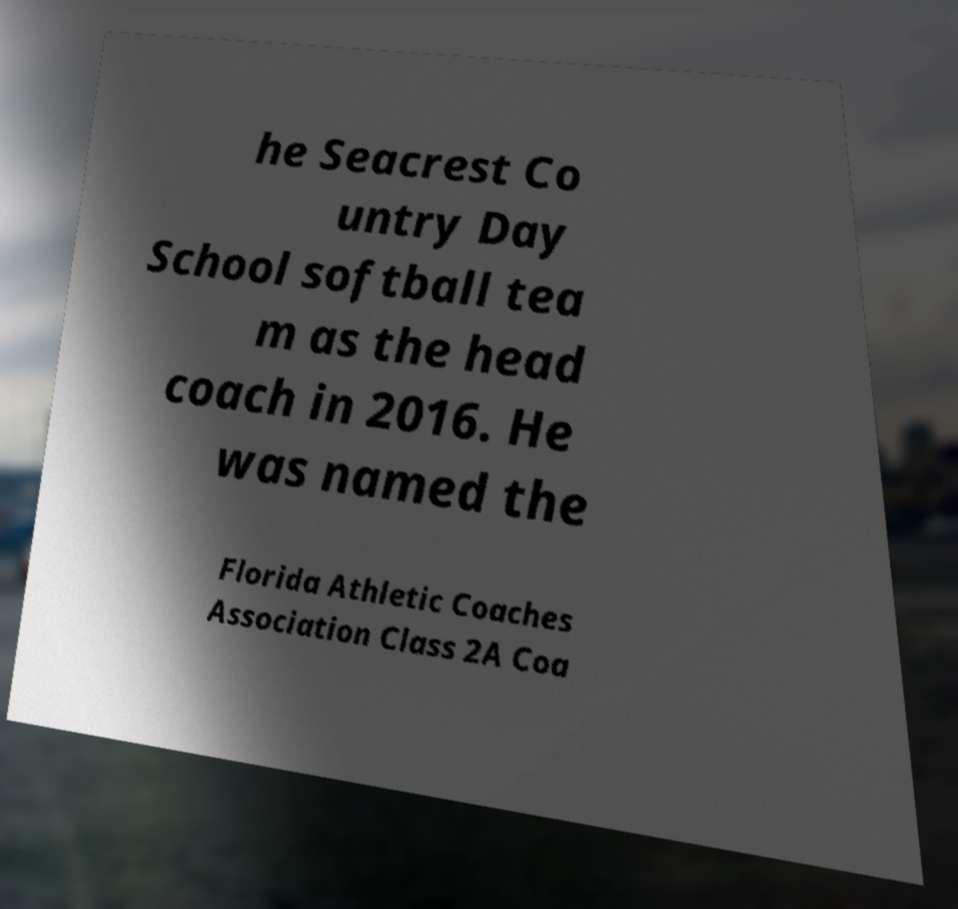Can you accurately transcribe the text from the provided image for me? he Seacrest Co untry Day School softball tea m as the head coach in 2016. He was named the Florida Athletic Coaches Association Class 2A Coa 